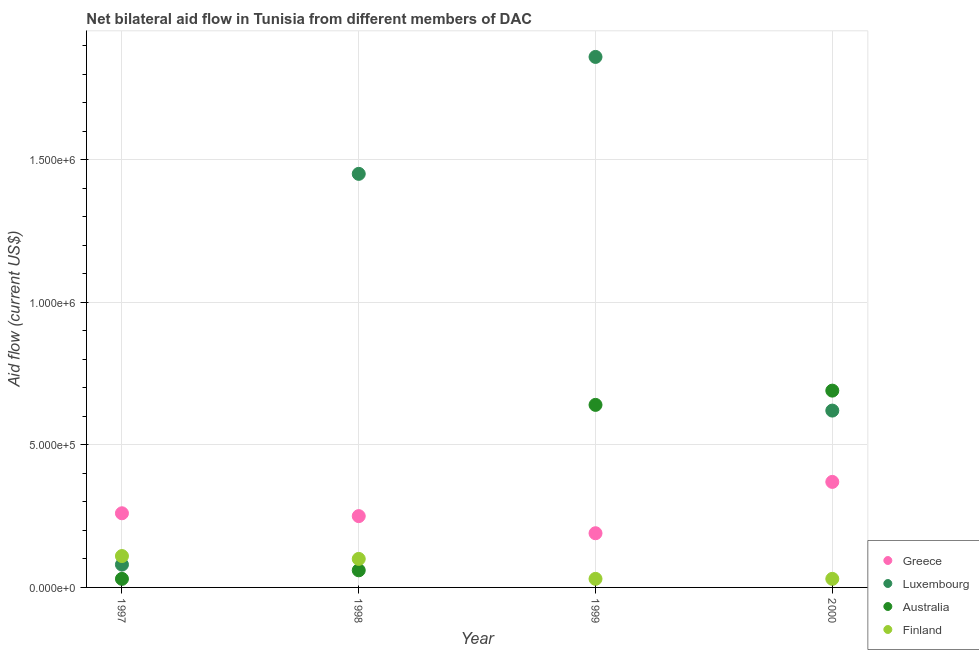What is the amount of aid given by australia in 1998?
Offer a very short reply. 6.00e+04. Across all years, what is the maximum amount of aid given by luxembourg?
Provide a succinct answer. 1.86e+06. Across all years, what is the minimum amount of aid given by finland?
Your answer should be compact. 3.00e+04. What is the total amount of aid given by finland in the graph?
Keep it short and to the point. 2.70e+05. What is the difference between the amount of aid given by australia in 1997 and that in 1998?
Offer a very short reply. -3.00e+04. What is the difference between the amount of aid given by luxembourg in 1999 and the amount of aid given by greece in 1998?
Provide a succinct answer. 1.61e+06. What is the average amount of aid given by australia per year?
Offer a very short reply. 3.55e+05. In the year 1998, what is the difference between the amount of aid given by australia and amount of aid given by luxembourg?
Provide a short and direct response. -1.39e+06. In how many years, is the amount of aid given by finland greater than 300000 US$?
Your response must be concise. 0. What is the ratio of the amount of aid given by finland in 1998 to that in 2000?
Your answer should be very brief. 3.33. Is the amount of aid given by australia in 1999 less than that in 2000?
Offer a very short reply. Yes. Is the difference between the amount of aid given by luxembourg in 1997 and 1998 greater than the difference between the amount of aid given by australia in 1997 and 1998?
Give a very brief answer. No. What is the difference between the highest and the second highest amount of aid given by luxembourg?
Your answer should be compact. 4.10e+05. What is the difference between the highest and the lowest amount of aid given by luxembourg?
Your answer should be very brief. 1.78e+06. Is it the case that in every year, the sum of the amount of aid given by greece and amount of aid given by luxembourg is greater than the sum of amount of aid given by australia and amount of aid given by finland?
Provide a succinct answer. Yes. Is it the case that in every year, the sum of the amount of aid given by greece and amount of aid given by luxembourg is greater than the amount of aid given by australia?
Make the answer very short. Yes. Where does the legend appear in the graph?
Give a very brief answer. Bottom right. How many legend labels are there?
Offer a terse response. 4. What is the title of the graph?
Keep it short and to the point. Net bilateral aid flow in Tunisia from different members of DAC. What is the label or title of the X-axis?
Keep it short and to the point. Year. What is the label or title of the Y-axis?
Provide a short and direct response. Aid flow (current US$). What is the Aid flow (current US$) of Luxembourg in 1997?
Give a very brief answer. 8.00e+04. What is the Aid flow (current US$) of Greece in 1998?
Provide a succinct answer. 2.50e+05. What is the Aid flow (current US$) of Luxembourg in 1998?
Provide a short and direct response. 1.45e+06. What is the Aid flow (current US$) in Greece in 1999?
Keep it short and to the point. 1.90e+05. What is the Aid flow (current US$) in Luxembourg in 1999?
Your answer should be very brief. 1.86e+06. What is the Aid flow (current US$) in Australia in 1999?
Provide a succinct answer. 6.40e+05. What is the Aid flow (current US$) of Luxembourg in 2000?
Offer a terse response. 6.20e+05. What is the Aid flow (current US$) of Australia in 2000?
Your answer should be very brief. 6.90e+05. Across all years, what is the maximum Aid flow (current US$) in Luxembourg?
Provide a succinct answer. 1.86e+06. Across all years, what is the maximum Aid flow (current US$) of Australia?
Keep it short and to the point. 6.90e+05. Across all years, what is the maximum Aid flow (current US$) of Finland?
Your response must be concise. 1.10e+05. Across all years, what is the minimum Aid flow (current US$) in Greece?
Make the answer very short. 1.90e+05. Across all years, what is the minimum Aid flow (current US$) in Luxembourg?
Provide a short and direct response. 8.00e+04. Across all years, what is the minimum Aid flow (current US$) of Finland?
Your response must be concise. 3.00e+04. What is the total Aid flow (current US$) of Greece in the graph?
Your response must be concise. 1.07e+06. What is the total Aid flow (current US$) in Luxembourg in the graph?
Offer a terse response. 4.01e+06. What is the total Aid flow (current US$) in Australia in the graph?
Make the answer very short. 1.42e+06. What is the difference between the Aid flow (current US$) of Luxembourg in 1997 and that in 1998?
Provide a succinct answer. -1.37e+06. What is the difference between the Aid flow (current US$) in Finland in 1997 and that in 1998?
Offer a very short reply. 10000. What is the difference between the Aid flow (current US$) in Greece in 1997 and that in 1999?
Ensure brevity in your answer.  7.00e+04. What is the difference between the Aid flow (current US$) in Luxembourg in 1997 and that in 1999?
Keep it short and to the point. -1.78e+06. What is the difference between the Aid flow (current US$) in Australia in 1997 and that in 1999?
Keep it short and to the point. -6.10e+05. What is the difference between the Aid flow (current US$) of Greece in 1997 and that in 2000?
Make the answer very short. -1.10e+05. What is the difference between the Aid flow (current US$) in Luxembourg in 1997 and that in 2000?
Give a very brief answer. -5.40e+05. What is the difference between the Aid flow (current US$) of Australia in 1997 and that in 2000?
Your answer should be very brief. -6.60e+05. What is the difference between the Aid flow (current US$) in Finland in 1997 and that in 2000?
Make the answer very short. 8.00e+04. What is the difference between the Aid flow (current US$) in Greece in 1998 and that in 1999?
Your answer should be very brief. 6.00e+04. What is the difference between the Aid flow (current US$) in Luxembourg in 1998 and that in 1999?
Your answer should be very brief. -4.10e+05. What is the difference between the Aid flow (current US$) in Australia in 1998 and that in 1999?
Provide a short and direct response. -5.80e+05. What is the difference between the Aid flow (current US$) in Finland in 1998 and that in 1999?
Provide a succinct answer. 7.00e+04. What is the difference between the Aid flow (current US$) in Greece in 1998 and that in 2000?
Your response must be concise. -1.20e+05. What is the difference between the Aid flow (current US$) in Luxembourg in 1998 and that in 2000?
Your answer should be very brief. 8.30e+05. What is the difference between the Aid flow (current US$) in Australia in 1998 and that in 2000?
Ensure brevity in your answer.  -6.30e+05. What is the difference between the Aid flow (current US$) in Finland in 1998 and that in 2000?
Ensure brevity in your answer.  7.00e+04. What is the difference between the Aid flow (current US$) of Luxembourg in 1999 and that in 2000?
Keep it short and to the point. 1.24e+06. What is the difference between the Aid flow (current US$) in Finland in 1999 and that in 2000?
Your answer should be compact. 0. What is the difference between the Aid flow (current US$) of Greece in 1997 and the Aid flow (current US$) of Luxembourg in 1998?
Give a very brief answer. -1.19e+06. What is the difference between the Aid flow (current US$) in Greece in 1997 and the Aid flow (current US$) in Australia in 1998?
Make the answer very short. 2.00e+05. What is the difference between the Aid flow (current US$) in Greece in 1997 and the Aid flow (current US$) in Finland in 1998?
Provide a succinct answer. 1.60e+05. What is the difference between the Aid flow (current US$) of Luxembourg in 1997 and the Aid flow (current US$) of Australia in 1998?
Offer a terse response. 2.00e+04. What is the difference between the Aid flow (current US$) of Luxembourg in 1997 and the Aid flow (current US$) of Finland in 1998?
Your response must be concise. -2.00e+04. What is the difference between the Aid flow (current US$) in Greece in 1997 and the Aid flow (current US$) in Luxembourg in 1999?
Your response must be concise. -1.60e+06. What is the difference between the Aid flow (current US$) of Greece in 1997 and the Aid flow (current US$) of Australia in 1999?
Your answer should be compact. -3.80e+05. What is the difference between the Aid flow (current US$) of Greece in 1997 and the Aid flow (current US$) of Finland in 1999?
Your answer should be compact. 2.30e+05. What is the difference between the Aid flow (current US$) in Luxembourg in 1997 and the Aid flow (current US$) in Australia in 1999?
Your answer should be compact. -5.60e+05. What is the difference between the Aid flow (current US$) in Greece in 1997 and the Aid flow (current US$) in Luxembourg in 2000?
Offer a terse response. -3.60e+05. What is the difference between the Aid flow (current US$) of Greece in 1997 and the Aid flow (current US$) of Australia in 2000?
Offer a terse response. -4.30e+05. What is the difference between the Aid flow (current US$) in Greece in 1997 and the Aid flow (current US$) in Finland in 2000?
Make the answer very short. 2.30e+05. What is the difference between the Aid flow (current US$) in Luxembourg in 1997 and the Aid flow (current US$) in Australia in 2000?
Offer a very short reply. -6.10e+05. What is the difference between the Aid flow (current US$) of Greece in 1998 and the Aid flow (current US$) of Luxembourg in 1999?
Your answer should be very brief. -1.61e+06. What is the difference between the Aid flow (current US$) in Greece in 1998 and the Aid flow (current US$) in Australia in 1999?
Offer a terse response. -3.90e+05. What is the difference between the Aid flow (current US$) in Greece in 1998 and the Aid flow (current US$) in Finland in 1999?
Give a very brief answer. 2.20e+05. What is the difference between the Aid flow (current US$) in Luxembourg in 1998 and the Aid flow (current US$) in Australia in 1999?
Make the answer very short. 8.10e+05. What is the difference between the Aid flow (current US$) in Luxembourg in 1998 and the Aid flow (current US$) in Finland in 1999?
Give a very brief answer. 1.42e+06. What is the difference between the Aid flow (current US$) in Australia in 1998 and the Aid flow (current US$) in Finland in 1999?
Make the answer very short. 3.00e+04. What is the difference between the Aid flow (current US$) of Greece in 1998 and the Aid flow (current US$) of Luxembourg in 2000?
Offer a very short reply. -3.70e+05. What is the difference between the Aid flow (current US$) in Greece in 1998 and the Aid flow (current US$) in Australia in 2000?
Ensure brevity in your answer.  -4.40e+05. What is the difference between the Aid flow (current US$) of Greece in 1998 and the Aid flow (current US$) of Finland in 2000?
Offer a very short reply. 2.20e+05. What is the difference between the Aid flow (current US$) in Luxembourg in 1998 and the Aid flow (current US$) in Australia in 2000?
Your response must be concise. 7.60e+05. What is the difference between the Aid flow (current US$) of Luxembourg in 1998 and the Aid flow (current US$) of Finland in 2000?
Provide a short and direct response. 1.42e+06. What is the difference between the Aid flow (current US$) of Greece in 1999 and the Aid flow (current US$) of Luxembourg in 2000?
Provide a succinct answer. -4.30e+05. What is the difference between the Aid flow (current US$) in Greece in 1999 and the Aid flow (current US$) in Australia in 2000?
Ensure brevity in your answer.  -5.00e+05. What is the difference between the Aid flow (current US$) in Greece in 1999 and the Aid flow (current US$) in Finland in 2000?
Provide a succinct answer. 1.60e+05. What is the difference between the Aid flow (current US$) of Luxembourg in 1999 and the Aid flow (current US$) of Australia in 2000?
Keep it short and to the point. 1.17e+06. What is the difference between the Aid flow (current US$) of Luxembourg in 1999 and the Aid flow (current US$) of Finland in 2000?
Provide a succinct answer. 1.83e+06. What is the difference between the Aid flow (current US$) of Australia in 1999 and the Aid flow (current US$) of Finland in 2000?
Offer a very short reply. 6.10e+05. What is the average Aid flow (current US$) in Greece per year?
Ensure brevity in your answer.  2.68e+05. What is the average Aid flow (current US$) in Luxembourg per year?
Ensure brevity in your answer.  1.00e+06. What is the average Aid flow (current US$) in Australia per year?
Give a very brief answer. 3.55e+05. What is the average Aid flow (current US$) in Finland per year?
Keep it short and to the point. 6.75e+04. In the year 1997, what is the difference between the Aid flow (current US$) of Greece and Aid flow (current US$) of Luxembourg?
Keep it short and to the point. 1.80e+05. In the year 1997, what is the difference between the Aid flow (current US$) of Greece and Aid flow (current US$) of Finland?
Your answer should be compact. 1.50e+05. In the year 1997, what is the difference between the Aid flow (current US$) in Luxembourg and Aid flow (current US$) in Australia?
Provide a short and direct response. 5.00e+04. In the year 1998, what is the difference between the Aid flow (current US$) of Greece and Aid flow (current US$) of Luxembourg?
Your answer should be very brief. -1.20e+06. In the year 1998, what is the difference between the Aid flow (current US$) of Greece and Aid flow (current US$) of Australia?
Keep it short and to the point. 1.90e+05. In the year 1998, what is the difference between the Aid flow (current US$) in Luxembourg and Aid flow (current US$) in Australia?
Your response must be concise. 1.39e+06. In the year 1998, what is the difference between the Aid flow (current US$) in Luxembourg and Aid flow (current US$) in Finland?
Provide a short and direct response. 1.35e+06. In the year 1998, what is the difference between the Aid flow (current US$) in Australia and Aid flow (current US$) in Finland?
Provide a succinct answer. -4.00e+04. In the year 1999, what is the difference between the Aid flow (current US$) in Greece and Aid flow (current US$) in Luxembourg?
Give a very brief answer. -1.67e+06. In the year 1999, what is the difference between the Aid flow (current US$) in Greece and Aid flow (current US$) in Australia?
Make the answer very short. -4.50e+05. In the year 1999, what is the difference between the Aid flow (current US$) in Greece and Aid flow (current US$) in Finland?
Provide a short and direct response. 1.60e+05. In the year 1999, what is the difference between the Aid flow (current US$) of Luxembourg and Aid flow (current US$) of Australia?
Offer a terse response. 1.22e+06. In the year 1999, what is the difference between the Aid flow (current US$) in Luxembourg and Aid flow (current US$) in Finland?
Keep it short and to the point. 1.83e+06. In the year 2000, what is the difference between the Aid flow (current US$) in Greece and Aid flow (current US$) in Luxembourg?
Provide a succinct answer. -2.50e+05. In the year 2000, what is the difference between the Aid flow (current US$) of Greece and Aid flow (current US$) of Australia?
Your response must be concise. -3.20e+05. In the year 2000, what is the difference between the Aid flow (current US$) in Luxembourg and Aid flow (current US$) in Australia?
Give a very brief answer. -7.00e+04. In the year 2000, what is the difference between the Aid flow (current US$) of Luxembourg and Aid flow (current US$) of Finland?
Give a very brief answer. 5.90e+05. In the year 2000, what is the difference between the Aid flow (current US$) in Australia and Aid flow (current US$) in Finland?
Keep it short and to the point. 6.60e+05. What is the ratio of the Aid flow (current US$) of Luxembourg in 1997 to that in 1998?
Offer a terse response. 0.06. What is the ratio of the Aid flow (current US$) in Australia in 1997 to that in 1998?
Provide a short and direct response. 0.5. What is the ratio of the Aid flow (current US$) in Finland in 1997 to that in 1998?
Provide a succinct answer. 1.1. What is the ratio of the Aid flow (current US$) of Greece in 1997 to that in 1999?
Your answer should be very brief. 1.37. What is the ratio of the Aid flow (current US$) in Luxembourg in 1997 to that in 1999?
Make the answer very short. 0.04. What is the ratio of the Aid flow (current US$) of Australia in 1997 to that in 1999?
Your answer should be very brief. 0.05. What is the ratio of the Aid flow (current US$) in Finland in 1997 to that in 1999?
Give a very brief answer. 3.67. What is the ratio of the Aid flow (current US$) in Greece in 1997 to that in 2000?
Provide a succinct answer. 0.7. What is the ratio of the Aid flow (current US$) of Luxembourg in 1997 to that in 2000?
Keep it short and to the point. 0.13. What is the ratio of the Aid flow (current US$) in Australia in 1997 to that in 2000?
Offer a terse response. 0.04. What is the ratio of the Aid flow (current US$) in Finland in 1997 to that in 2000?
Ensure brevity in your answer.  3.67. What is the ratio of the Aid flow (current US$) of Greece in 1998 to that in 1999?
Offer a terse response. 1.32. What is the ratio of the Aid flow (current US$) in Luxembourg in 1998 to that in 1999?
Offer a terse response. 0.78. What is the ratio of the Aid flow (current US$) of Australia in 1998 to that in 1999?
Your answer should be compact. 0.09. What is the ratio of the Aid flow (current US$) in Finland in 1998 to that in 1999?
Ensure brevity in your answer.  3.33. What is the ratio of the Aid flow (current US$) of Greece in 1998 to that in 2000?
Your response must be concise. 0.68. What is the ratio of the Aid flow (current US$) of Luxembourg in 1998 to that in 2000?
Offer a terse response. 2.34. What is the ratio of the Aid flow (current US$) of Australia in 1998 to that in 2000?
Give a very brief answer. 0.09. What is the ratio of the Aid flow (current US$) in Greece in 1999 to that in 2000?
Ensure brevity in your answer.  0.51. What is the ratio of the Aid flow (current US$) of Australia in 1999 to that in 2000?
Keep it short and to the point. 0.93. What is the difference between the highest and the second highest Aid flow (current US$) of Greece?
Your response must be concise. 1.10e+05. What is the difference between the highest and the second highest Aid flow (current US$) in Luxembourg?
Ensure brevity in your answer.  4.10e+05. What is the difference between the highest and the second highest Aid flow (current US$) in Australia?
Your response must be concise. 5.00e+04. What is the difference between the highest and the second highest Aid flow (current US$) in Finland?
Your response must be concise. 10000. What is the difference between the highest and the lowest Aid flow (current US$) of Greece?
Your response must be concise. 1.80e+05. What is the difference between the highest and the lowest Aid flow (current US$) in Luxembourg?
Your answer should be compact. 1.78e+06. What is the difference between the highest and the lowest Aid flow (current US$) of Finland?
Offer a terse response. 8.00e+04. 